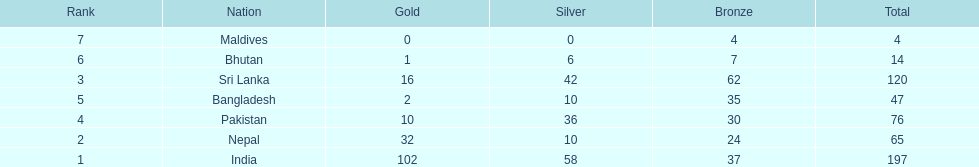Who has won the most bronze medals? Sri Lanka. 